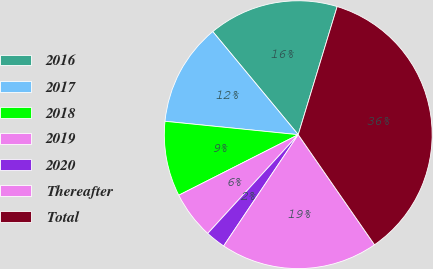Convert chart. <chart><loc_0><loc_0><loc_500><loc_500><pie_chart><fcel>2016<fcel>2017<fcel>2018<fcel>2019<fcel>2020<fcel>Thereafter<fcel>Total<nl><fcel>15.71%<fcel>12.39%<fcel>9.06%<fcel>5.73%<fcel>2.41%<fcel>19.04%<fcel>35.66%<nl></chart> 